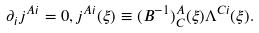<formula> <loc_0><loc_0><loc_500><loc_500>\partial _ { i } j ^ { A i } = 0 , j ^ { A i } ( \xi ) \equiv ( B ^ { - 1 } ) _ { C } ^ { A } ( \xi ) \Lambda ^ { C i } ( \xi ) .</formula> 